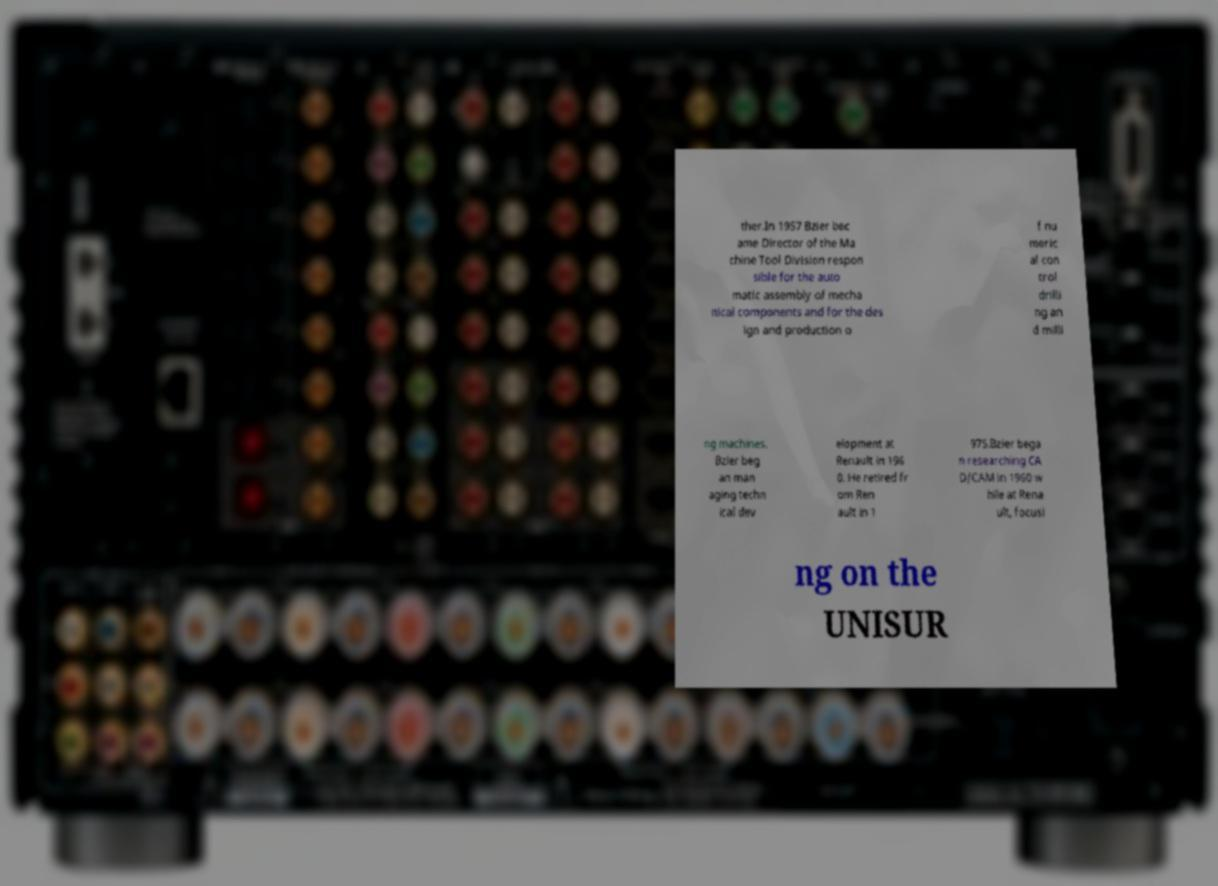For documentation purposes, I need the text within this image transcribed. Could you provide that? ther.In 1957 Bzier bec ame Director of the Ma chine Tool Division respon sible for the auto matic assembly of mecha nical components and for the des ign and production o f nu meric al con trol drilli ng an d milli ng machines. Bzier beg an man aging techn ical dev elopment at Renault in 196 0. He retired fr om Ren ault in 1 975.Bzier bega n researching CA D/CAM in 1960 w hile at Rena ult, focusi ng on the UNISUR 